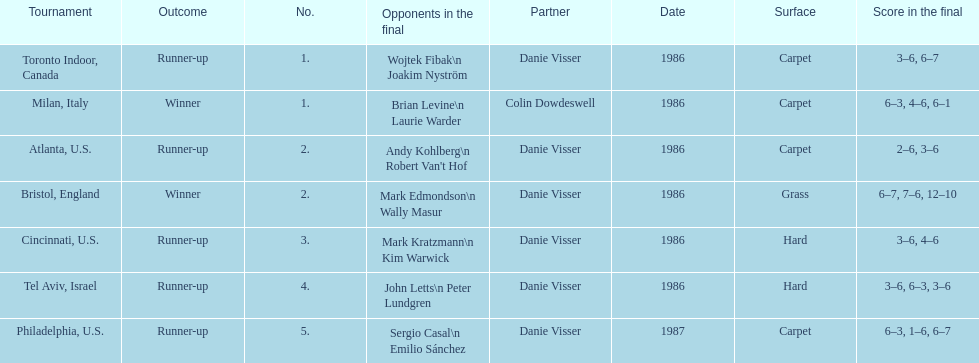What's the total of grass and hard surfaces listed? 3. 